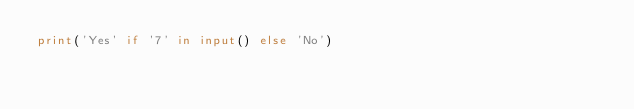<code> <loc_0><loc_0><loc_500><loc_500><_Python_>print('Yes' if '7' in input() else 'No')
</code> 